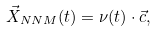Convert formula to latex. <formula><loc_0><loc_0><loc_500><loc_500>\vec { X } _ { N N M } ( t ) = \nu ( t ) \cdot \vec { c } ,</formula> 